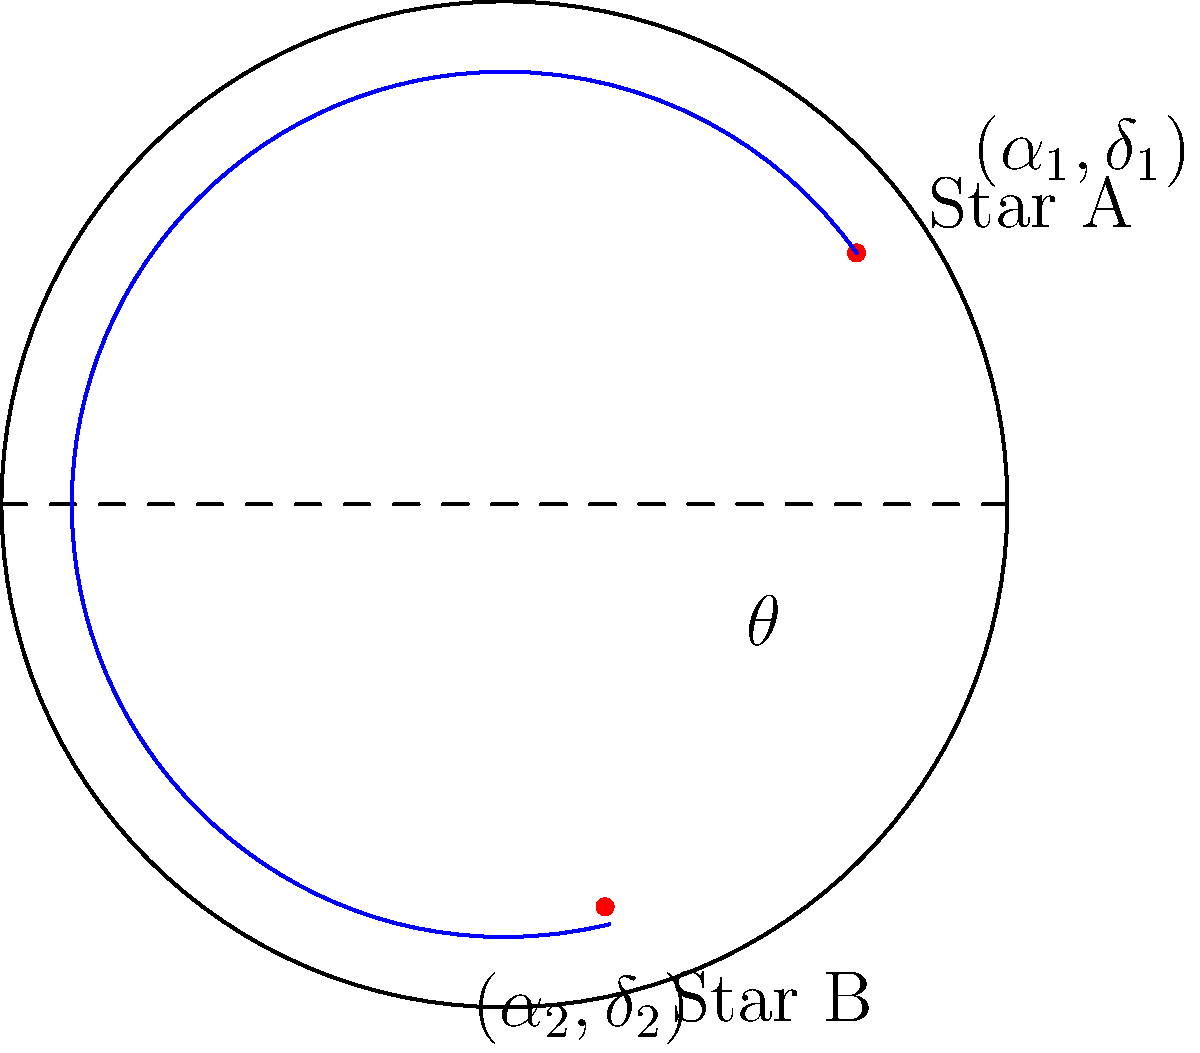Given two stars with celestial coordinates $(\alpha_1,\delta_1)$ and $(\alpha_2,\delta_2)$, where $\alpha$ represents right ascension and $\delta$ represents declination, implement a function to calculate the angular separation $\theta$ between them using the haversine formula. How would you design this function to ensure it's decoupled from any specific coordinate system implementation? To calculate the angular separation between two stars given their celestial coordinates, we can use the haversine formula. Here's a step-by-step explanation of the process and how to implement it in a decoupled manner:

1. The haversine formula for angular separation is:

   $$\theta = 2 \arcsin\left(\sqrt{\sin^2\left(\frac{\delta_2 - \delta_1}{2}\right) + \cos(\delta_1)\cos(\delta_2)\sin^2\left(\frac{\alpha_2 - \alpha_1}{2}\right)}\right)$$

2. To implement this in a decoupled manner, we can create an interface `CelestialCoordinate` with methods to get right ascension and declination:

   ```java
   public interface CelestialCoordinate {
       double getRightAscension();
       double getDeclination();
   }
   ```

3. Implement a function that takes two `CelestialCoordinate` objects as parameters:

   ```java
   public static double calculateAngularSeparation(CelestialCoordinate star1, CelestialCoordinate star2) {
       double alpha1 = Math.toRadians(star1.getRightAscension());
       double delta1 = Math.toRadians(star1.getDeclination());
       double alpha2 = Math.toRadians(star2.getRightAscension());
       double delta2 = Math.toRadians(star2.getDeclination());

       double deltaAlpha = alpha2 - alpha1;
       double deltaDelta = delta2 - delta1;

       double haversine = Math.sin(deltaDelta/2) * Math.sin(deltaDelta/2) +
                          Math.cos(delta1) * Math.cos(delta2) *
                          Math.sin(deltaAlpha/2) * Math.sin(deltaAlpha/2);

       return 2 * Math.asin(Math.sqrt(haversine));
   }
   ```

4. This implementation is decoupled from any specific coordinate system, as it relies on the interface rather than concrete implementations. It also avoids reflection by using well-defined method calls.

5. To use this function, any class representing celestial coordinates would need to implement the `CelestialCoordinate` interface, ensuring loose coupling and easy extensibility.
Answer: Implement a function that takes two `CelestialCoordinate` objects, calculates angular separation using the haversine formula, and returns the result in radians. 